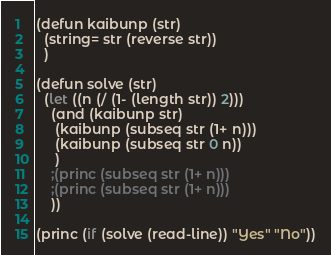Convert code to text. <code><loc_0><loc_0><loc_500><loc_500><_Lisp_>(defun kaibunp (str)
  (string= str (reverse str))
  )

(defun solve (str)
  (let ((n (/ (1- (length str)) 2)))
    (and (kaibunp str)
	 (kaibunp (subseq str (1+ n)))
	 (kaibunp (subseq str 0 n))
	 )
    ;(princ (subseq str (1+ n)))
    ;(princ (subseq str (1+ n)))
    ))

(princ (if (solve (read-line)) "Yes" "No"))</code> 